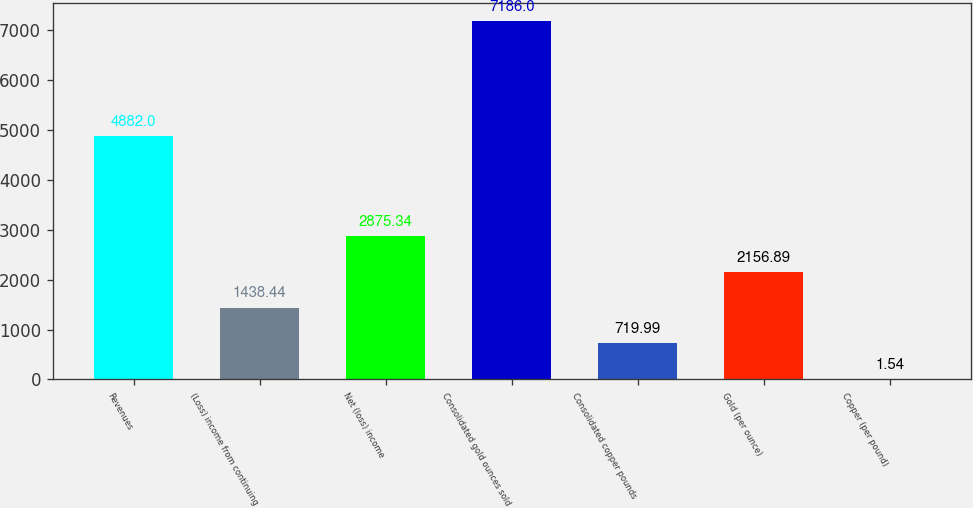Convert chart to OTSL. <chart><loc_0><loc_0><loc_500><loc_500><bar_chart><fcel>Revenues<fcel>(Loss) income from continuing<fcel>Net (loss) income<fcel>Consolidated gold ounces sold<fcel>Consolidated copper pounds<fcel>Gold (per ounce)<fcel>Copper (per pound)<nl><fcel>4882<fcel>1438.44<fcel>2875.34<fcel>7186<fcel>719.99<fcel>2156.89<fcel>1.54<nl></chart> 